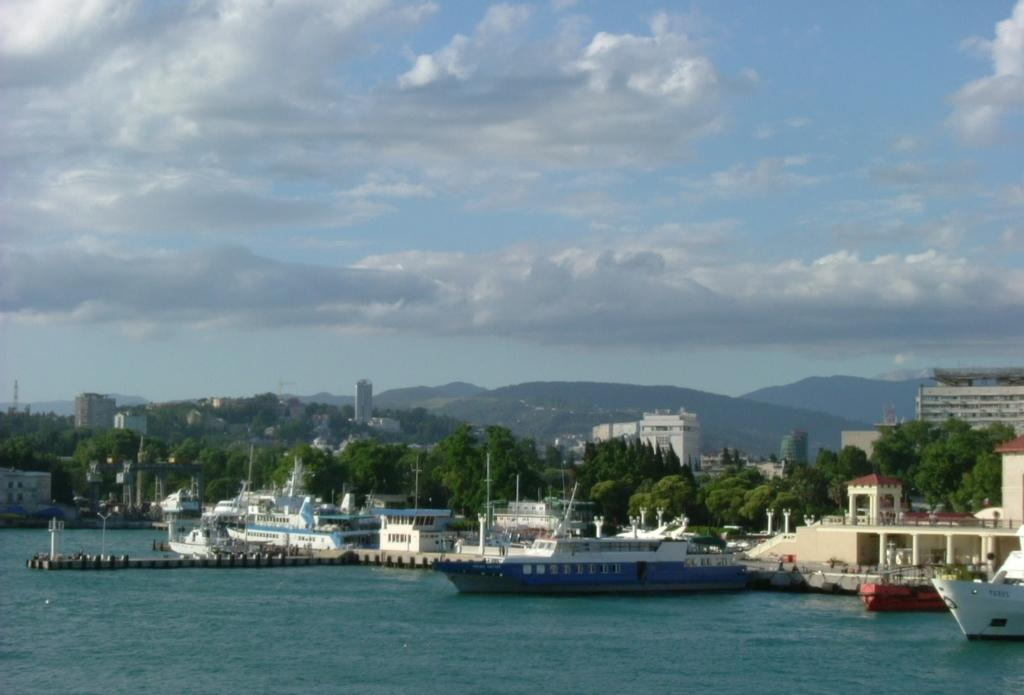What is on the water in the image? There are ships on the water in the image. What type of structure can be seen in the image? There is a walkway bridge in the image. What are the vertical structures in the image? There are poles in the image. What type of vegetation is present in the image? There are trees in the image. What type of man-made structures are visible in the image? There are buildings in the image. What type of natural landform is present in the image? There are hills in the image. What is visible above the land and water in the image? The sky is visible in the image. What can be seen in the sky in the image? There are clouds in the sky. What type of powder is being used to create the frame of the walkway bridge in the image? There is no mention of powder or a frame for the walkway bridge in the image. The bridge appears to be a solid structure. 